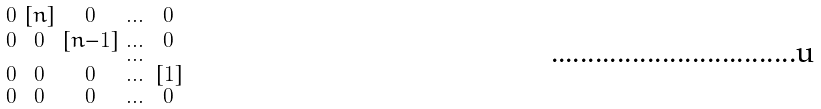<formula> <loc_0><loc_0><loc_500><loc_500>\begin{smallmatrix} 0 & [ n ] & 0 & \dots & 0 \\ 0 & 0 & [ n - 1 ] & \dots & 0 \\ & & & \dots & \\ 0 & 0 & 0 & \dots & [ 1 ] \\ 0 & 0 & 0 & \dots & 0 \end{smallmatrix}</formula> 